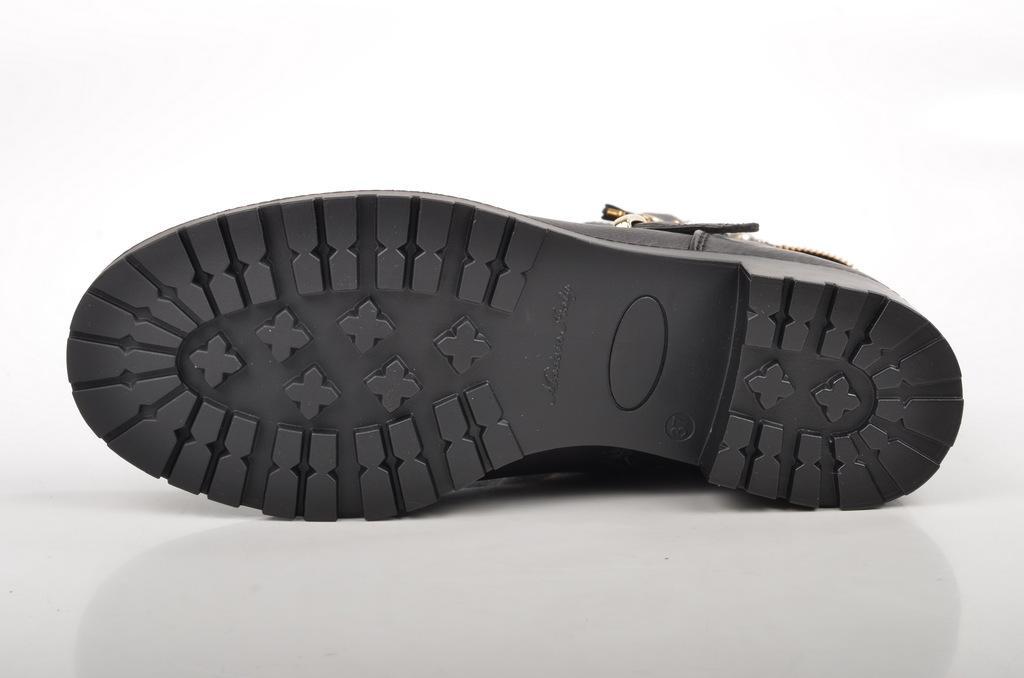In one or two sentences, can you explain what this image depicts? In the foreground of this image, there is a shoe sole on the white surface. 